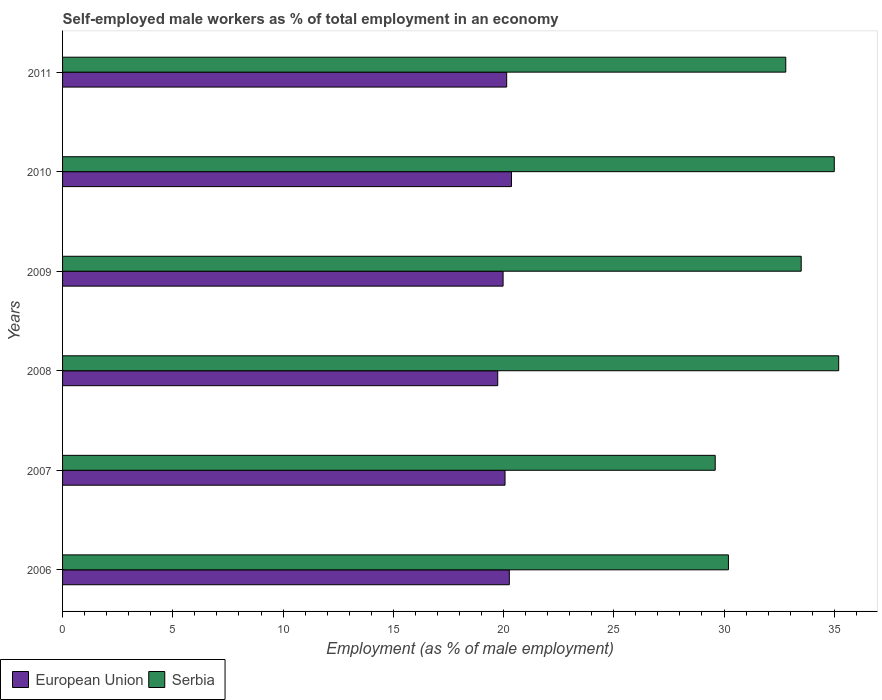How many groups of bars are there?
Provide a short and direct response. 6. Are the number of bars per tick equal to the number of legend labels?
Your response must be concise. Yes. Are the number of bars on each tick of the Y-axis equal?
Provide a succinct answer. Yes. How many bars are there on the 1st tick from the top?
Offer a terse response. 2. In how many cases, is the number of bars for a given year not equal to the number of legend labels?
Provide a succinct answer. 0. What is the percentage of self-employed male workers in European Union in 2006?
Your answer should be compact. 20.26. Across all years, what is the maximum percentage of self-employed male workers in European Union?
Give a very brief answer. 20.36. Across all years, what is the minimum percentage of self-employed male workers in European Union?
Give a very brief answer. 19.74. In which year was the percentage of self-employed male workers in Serbia maximum?
Provide a short and direct response. 2008. What is the total percentage of self-employed male workers in Serbia in the graph?
Give a very brief answer. 196.3. What is the difference between the percentage of self-employed male workers in Serbia in 2009 and that in 2011?
Offer a terse response. 0.7. What is the difference between the percentage of self-employed male workers in European Union in 2006 and the percentage of self-employed male workers in Serbia in 2008?
Make the answer very short. -14.94. What is the average percentage of self-employed male workers in European Union per year?
Offer a terse response. 20.09. In the year 2011, what is the difference between the percentage of self-employed male workers in Serbia and percentage of self-employed male workers in European Union?
Offer a very short reply. 12.66. What is the ratio of the percentage of self-employed male workers in Serbia in 2007 to that in 2008?
Your response must be concise. 0.84. Is the percentage of self-employed male workers in Serbia in 2009 less than that in 2011?
Ensure brevity in your answer.  No. Is the difference between the percentage of self-employed male workers in Serbia in 2008 and 2010 greater than the difference between the percentage of self-employed male workers in European Union in 2008 and 2010?
Offer a terse response. Yes. What is the difference between the highest and the second highest percentage of self-employed male workers in Serbia?
Your answer should be compact. 0.2. What is the difference between the highest and the lowest percentage of self-employed male workers in Serbia?
Give a very brief answer. 5.6. In how many years, is the percentage of self-employed male workers in European Union greater than the average percentage of self-employed male workers in European Union taken over all years?
Your response must be concise. 3. Is the sum of the percentage of self-employed male workers in European Union in 2006 and 2010 greater than the maximum percentage of self-employed male workers in Serbia across all years?
Make the answer very short. Yes. What does the 2nd bar from the top in 2008 represents?
Your answer should be compact. European Union. What does the 1st bar from the bottom in 2011 represents?
Your answer should be very brief. European Union. Are all the bars in the graph horizontal?
Give a very brief answer. Yes. Does the graph contain any zero values?
Keep it short and to the point. No. Where does the legend appear in the graph?
Give a very brief answer. Bottom left. How many legend labels are there?
Provide a succinct answer. 2. What is the title of the graph?
Ensure brevity in your answer.  Self-employed male workers as % of total employment in an economy. What is the label or title of the X-axis?
Offer a very short reply. Employment (as % of male employment). What is the label or title of the Y-axis?
Provide a short and direct response. Years. What is the Employment (as % of male employment) of European Union in 2006?
Provide a succinct answer. 20.26. What is the Employment (as % of male employment) of Serbia in 2006?
Your response must be concise. 30.2. What is the Employment (as % of male employment) of European Union in 2007?
Provide a succinct answer. 20.07. What is the Employment (as % of male employment) in Serbia in 2007?
Make the answer very short. 29.6. What is the Employment (as % of male employment) in European Union in 2008?
Keep it short and to the point. 19.74. What is the Employment (as % of male employment) of Serbia in 2008?
Offer a terse response. 35.2. What is the Employment (as % of male employment) in European Union in 2009?
Provide a succinct answer. 19.98. What is the Employment (as % of male employment) of Serbia in 2009?
Ensure brevity in your answer.  33.5. What is the Employment (as % of male employment) of European Union in 2010?
Ensure brevity in your answer.  20.36. What is the Employment (as % of male employment) in Serbia in 2010?
Your answer should be compact. 35. What is the Employment (as % of male employment) in European Union in 2011?
Your answer should be very brief. 20.14. What is the Employment (as % of male employment) of Serbia in 2011?
Ensure brevity in your answer.  32.8. Across all years, what is the maximum Employment (as % of male employment) in European Union?
Your response must be concise. 20.36. Across all years, what is the maximum Employment (as % of male employment) of Serbia?
Your answer should be very brief. 35.2. Across all years, what is the minimum Employment (as % of male employment) in European Union?
Provide a succinct answer. 19.74. Across all years, what is the minimum Employment (as % of male employment) of Serbia?
Ensure brevity in your answer.  29.6. What is the total Employment (as % of male employment) in European Union in the graph?
Your response must be concise. 120.55. What is the total Employment (as % of male employment) of Serbia in the graph?
Provide a succinct answer. 196.3. What is the difference between the Employment (as % of male employment) of European Union in 2006 and that in 2007?
Keep it short and to the point. 0.19. What is the difference between the Employment (as % of male employment) in Serbia in 2006 and that in 2007?
Your answer should be compact. 0.6. What is the difference between the Employment (as % of male employment) in European Union in 2006 and that in 2008?
Your response must be concise. 0.53. What is the difference between the Employment (as % of male employment) in European Union in 2006 and that in 2009?
Your response must be concise. 0.28. What is the difference between the Employment (as % of male employment) in Serbia in 2006 and that in 2009?
Make the answer very short. -3.3. What is the difference between the Employment (as % of male employment) in European Union in 2006 and that in 2010?
Provide a short and direct response. -0.1. What is the difference between the Employment (as % of male employment) in Serbia in 2006 and that in 2010?
Give a very brief answer. -4.8. What is the difference between the Employment (as % of male employment) in European Union in 2006 and that in 2011?
Provide a succinct answer. 0.12. What is the difference between the Employment (as % of male employment) of European Union in 2007 and that in 2008?
Provide a short and direct response. 0.33. What is the difference between the Employment (as % of male employment) in European Union in 2007 and that in 2009?
Your response must be concise. 0.09. What is the difference between the Employment (as % of male employment) in Serbia in 2007 and that in 2009?
Your answer should be very brief. -3.9. What is the difference between the Employment (as % of male employment) in European Union in 2007 and that in 2010?
Your answer should be very brief. -0.29. What is the difference between the Employment (as % of male employment) in European Union in 2007 and that in 2011?
Offer a very short reply. -0.08. What is the difference between the Employment (as % of male employment) of European Union in 2008 and that in 2009?
Your response must be concise. -0.24. What is the difference between the Employment (as % of male employment) in Serbia in 2008 and that in 2009?
Provide a succinct answer. 1.7. What is the difference between the Employment (as % of male employment) of European Union in 2008 and that in 2010?
Make the answer very short. -0.62. What is the difference between the Employment (as % of male employment) in Serbia in 2008 and that in 2010?
Give a very brief answer. 0.2. What is the difference between the Employment (as % of male employment) of European Union in 2008 and that in 2011?
Provide a short and direct response. -0.41. What is the difference between the Employment (as % of male employment) in Serbia in 2008 and that in 2011?
Offer a very short reply. 2.4. What is the difference between the Employment (as % of male employment) in European Union in 2009 and that in 2010?
Your response must be concise. -0.38. What is the difference between the Employment (as % of male employment) in European Union in 2009 and that in 2011?
Give a very brief answer. -0.16. What is the difference between the Employment (as % of male employment) in European Union in 2010 and that in 2011?
Make the answer very short. 0.22. What is the difference between the Employment (as % of male employment) of European Union in 2006 and the Employment (as % of male employment) of Serbia in 2007?
Provide a short and direct response. -9.34. What is the difference between the Employment (as % of male employment) of European Union in 2006 and the Employment (as % of male employment) of Serbia in 2008?
Your response must be concise. -14.94. What is the difference between the Employment (as % of male employment) in European Union in 2006 and the Employment (as % of male employment) in Serbia in 2009?
Your response must be concise. -13.24. What is the difference between the Employment (as % of male employment) in European Union in 2006 and the Employment (as % of male employment) in Serbia in 2010?
Your answer should be very brief. -14.74. What is the difference between the Employment (as % of male employment) in European Union in 2006 and the Employment (as % of male employment) in Serbia in 2011?
Make the answer very short. -12.54. What is the difference between the Employment (as % of male employment) in European Union in 2007 and the Employment (as % of male employment) in Serbia in 2008?
Keep it short and to the point. -15.13. What is the difference between the Employment (as % of male employment) in European Union in 2007 and the Employment (as % of male employment) in Serbia in 2009?
Provide a short and direct response. -13.43. What is the difference between the Employment (as % of male employment) of European Union in 2007 and the Employment (as % of male employment) of Serbia in 2010?
Offer a very short reply. -14.93. What is the difference between the Employment (as % of male employment) in European Union in 2007 and the Employment (as % of male employment) in Serbia in 2011?
Your answer should be very brief. -12.73. What is the difference between the Employment (as % of male employment) of European Union in 2008 and the Employment (as % of male employment) of Serbia in 2009?
Offer a terse response. -13.76. What is the difference between the Employment (as % of male employment) in European Union in 2008 and the Employment (as % of male employment) in Serbia in 2010?
Your answer should be compact. -15.26. What is the difference between the Employment (as % of male employment) of European Union in 2008 and the Employment (as % of male employment) of Serbia in 2011?
Offer a very short reply. -13.06. What is the difference between the Employment (as % of male employment) in European Union in 2009 and the Employment (as % of male employment) in Serbia in 2010?
Keep it short and to the point. -15.02. What is the difference between the Employment (as % of male employment) in European Union in 2009 and the Employment (as % of male employment) in Serbia in 2011?
Give a very brief answer. -12.82. What is the difference between the Employment (as % of male employment) of European Union in 2010 and the Employment (as % of male employment) of Serbia in 2011?
Provide a short and direct response. -12.44. What is the average Employment (as % of male employment) in European Union per year?
Offer a very short reply. 20.09. What is the average Employment (as % of male employment) of Serbia per year?
Make the answer very short. 32.72. In the year 2006, what is the difference between the Employment (as % of male employment) of European Union and Employment (as % of male employment) of Serbia?
Provide a short and direct response. -9.94. In the year 2007, what is the difference between the Employment (as % of male employment) of European Union and Employment (as % of male employment) of Serbia?
Your response must be concise. -9.53. In the year 2008, what is the difference between the Employment (as % of male employment) of European Union and Employment (as % of male employment) of Serbia?
Your response must be concise. -15.46. In the year 2009, what is the difference between the Employment (as % of male employment) of European Union and Employment (as % of male employment) of Serbia?
Your answer should be very brief. -13.52. In the year 2010, what is the difference between the Employment (as % of male employment) of European Union and Employment (as % of male employment) of Serbia?
Give a very brief answer. -14.64. In the year 2011, what is the difference between the Employment (as % of male employment) in European Union and Employment (as % of male employment) in Serbia?
Provide a succinct answer. -12.66. What is the ratio of the Employment (as % of male employment) of European Union in 2006 to that in 2007?
Keep it short and to the point. 1.01. What is the ratio of the Employment (as % of male employment) in Serbia in 2006 to that in 2007?
Your answer should be compact. 1.02. What is the ratio of the Employment (as % of male employment) in European Union in 2006 to that in 2008?
Your response must be concise. 1.03. What is the ratio of the Employment (as % of male employment) in Serbia in 2006 to that in 2008?
Offer a terse response. 0.86. What is the ratio of the Employment (as % of male employment) in European Union in 2006 to that in 2009?
Your answer should be compact. 1.01. What is the ratio of the Employment (as % of male employment) in Serbia in 2006 to that in 2009?
Your answer should be very brief. 0.9. What is the ratio of the Employment (as % of male employment) in Serbia in 2006 to that in 2010?
Ensure brevity in your answer.  0.86. What is the ratio of the Employment (as % of male employment) in European Union in 2006 to that in 2011?
Ensure brevity in your answer.  1.01. What is the ratio of the Employment (as % of male employment) in Serbia in 2006 to that in 2011?
Offer a very short reply. 0.92. What is the ratio of the Employment (as % of male employment) in European Union in 2007 to that in 2008?
Make the answer very short. 1.02. What is the ratio of the Employment (as % of male employment) of Serbia in 2007 to that in 2008?
Ensure brevity in your answer.  0.84. What is the ratio of the Employment (as % of male employment) in Serbia in 2007 to that in 2009?
Your response must be concise. 0.88. What is the ratio of the Employment (as % of male employment) of European Union in 2007 to that in 2010?
Give a very brief answer. 0.99. What is the ratio of the Employment (as % of male employment) of Serbia in 2007 to that in 2010?
Your answer should be very brief. 0.85. What is the ratio of the Employment (as % of male employment) in Serbia in 2007 to that in 2011?
Provide a short and direct response. 0.9. What is the ratio of the Employment (as % of male employment) of European Union in 2008 to that in 2009?
Provide a succinct answer. 0.99. What is the ratio of the Employment (as % of male employment) in Serbia in 2008 to that in 2009?
Keep it short and to the point. 1.05. What is the ratio of the Employment (as % of male employment) of European Union in 2008 to that in 2010?
Your response must be concise. 0.97. What is the ratio of the Employment (as % of male employment) of European Union in 2008 to that in 2011?
Keep it short and to the point. 0.98. What is the ratio of the Employment (as % of male employment) in Serbia in 2008 to that in 2011?
Offer a terse response. 1.07. What is the ratio of the Employment (as % of male employment) of European Union in 2009 to that in 2010?
Provide a short and direct response. 0.98. What is the ratio of the Employment (as % of male employment) of Serbia in 2009 to that in 2010?
Your answer should be very brief. 0.96. What is the ratio of the Employment (as % of male employment) in Serbia in 2009 to that in 2011?
Provide a succinct answer. 1.02. What is the ratio of the Employment (as % of male employment) in European Union in 2010 to that in 2011?
Offer a terse response. 1.01. What is the ratio of the Employment (as % of male employment) in Serbia in 2010 to that in 2011?
Your answer should be compact. 1.07. What is the difference between the highest and the second highest Employment (as % of male employment) in European Union?
Keep it short and to the point. 0.1. What is the difference between the highest and the lowest Employment (as % of male employment) in European Union?
Give a very brief answer. 0.62. 